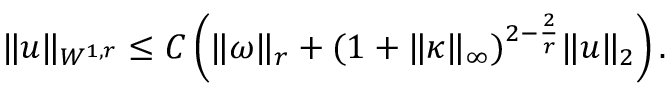<formula> <loc_0><loc_0><loc_500><loc_500>\begin{array} { r } { \| u \| _ { W ^ { 1 , r } } \leq C \left ( \| \omega \| _ { r } + ( 1 + \| \kappa \| _ { \infty } ) ^ { 2 - \frac { 2 } { r } } \| u \| _ { 2 } \right ) . } \end{array}</formula> 